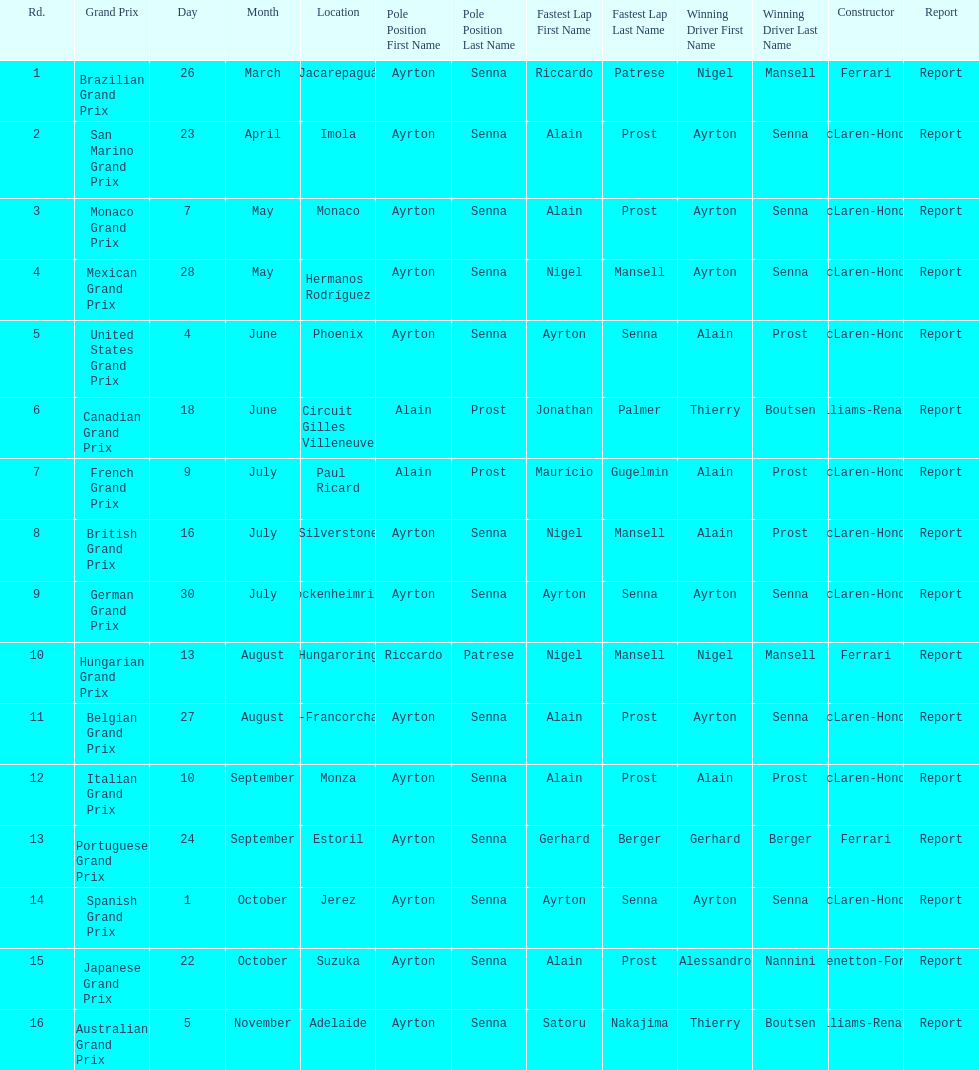What was the only grand prix to be won by benneton-ford? Japanese Grand Prix. 